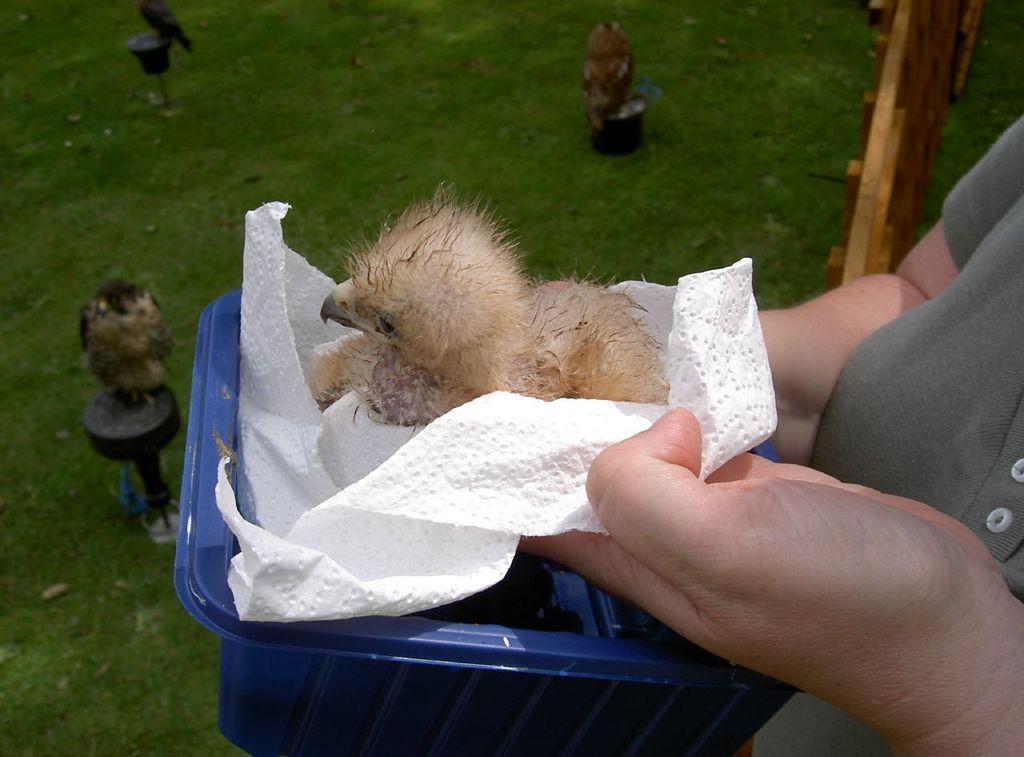How would you summarize this image in a sentence or two? Here in this picture we can see a chick present on a tissue paper and it is held by a person over there and she is also holding a blue colored basket in her hand and in front of her we can see the ground is fully covered with grass over there and we can see other birds present here and there. 